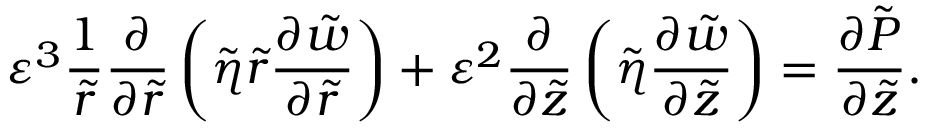<formula> <loc_0><loc_0><loc_500><loc_500>\varepsilon ^ { 3 } \frac { 1 } { \tilde { r } } \frac { \partial } { \partial \tilde { r } } \left ( \tilde { \eta } \tilde { r } \frac { \partial \tilde { w } } { \partial \tilde { r } } \right ) + \varepsilon ^ { 2 } \frac { \partial } { \partial \tilde { z } } \left ( \tilde { \eta } \frac { \partial \tilde { w } } { \partial \tilde { z } } \right ) = \frac { \partial \tilde { P } } { \partial \tilde { z } } .</formula> 